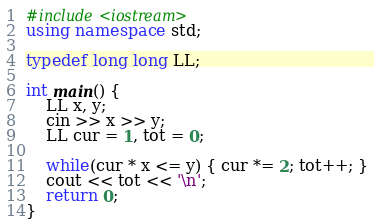Convert code to text. <code><loc_0><loc_0><loc_500><loc_500><_C++_>#include<iostream>
using namespace std;

typedef long long LL;

int main() {
    LL x, y;
    cin >> x >> y;
    LL cur = 1, tot = 0;

    while(cur * x <= y) { cur *= 2; tot++; }
    cout << tot << '\n';
    return 0;
}</code> 